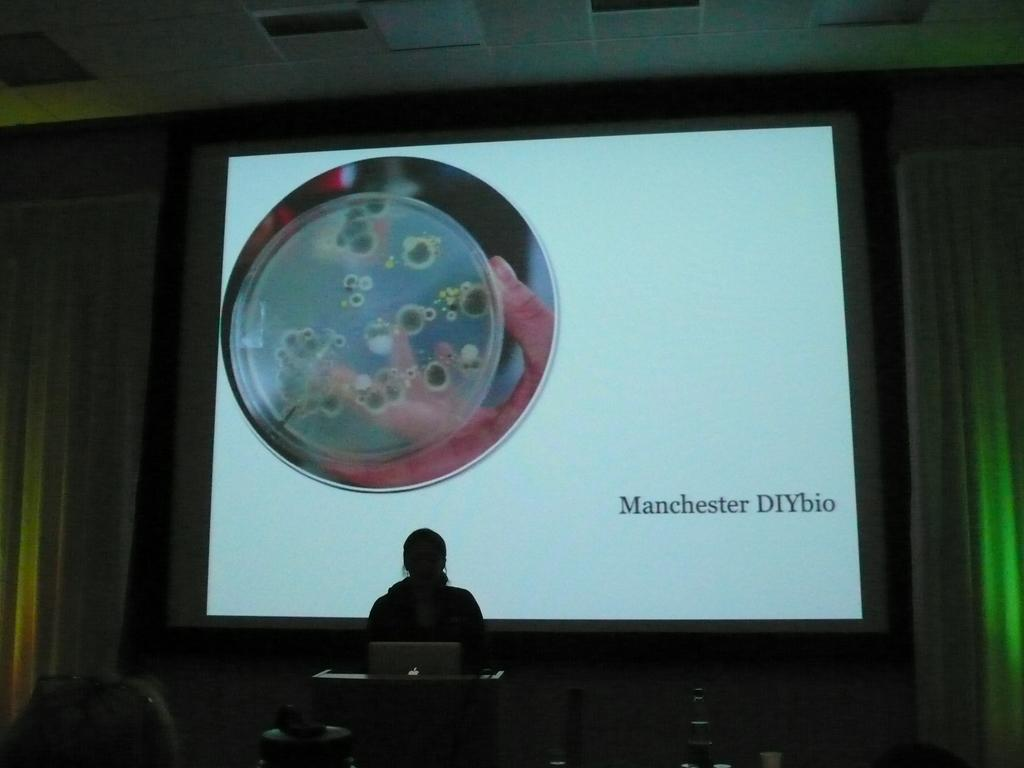Who or what is located at the bottom of the image? There is a person standing at the bottom of the image. What object can be seen in front of the person? There is a podium in the image. What is placed on the podium? A laptop is placed on the podium. What can be seen in the background of the image? There is a screen and curtains in the background of the image. What type of condition does the robin have in the image? There is no robin present in the image, so it is not possible to determine any condition it might have. 